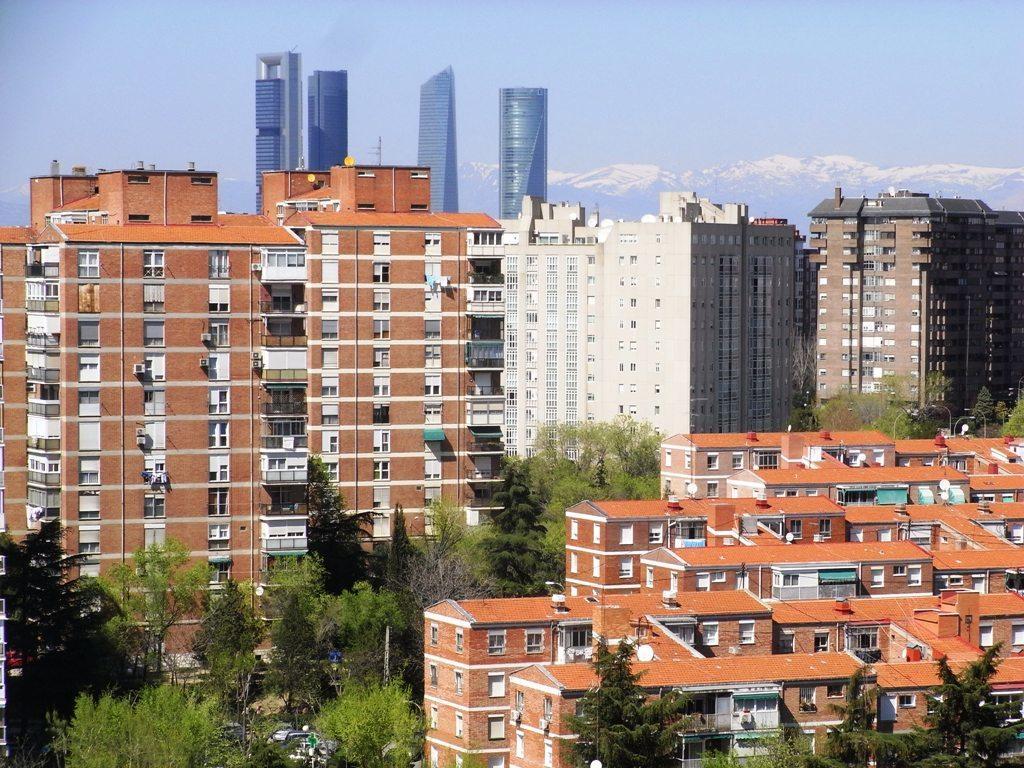Could you give a brief overview of what you see in this image? In the background we can see sky, huge buildings. In this picture we can see buildings and trees. 